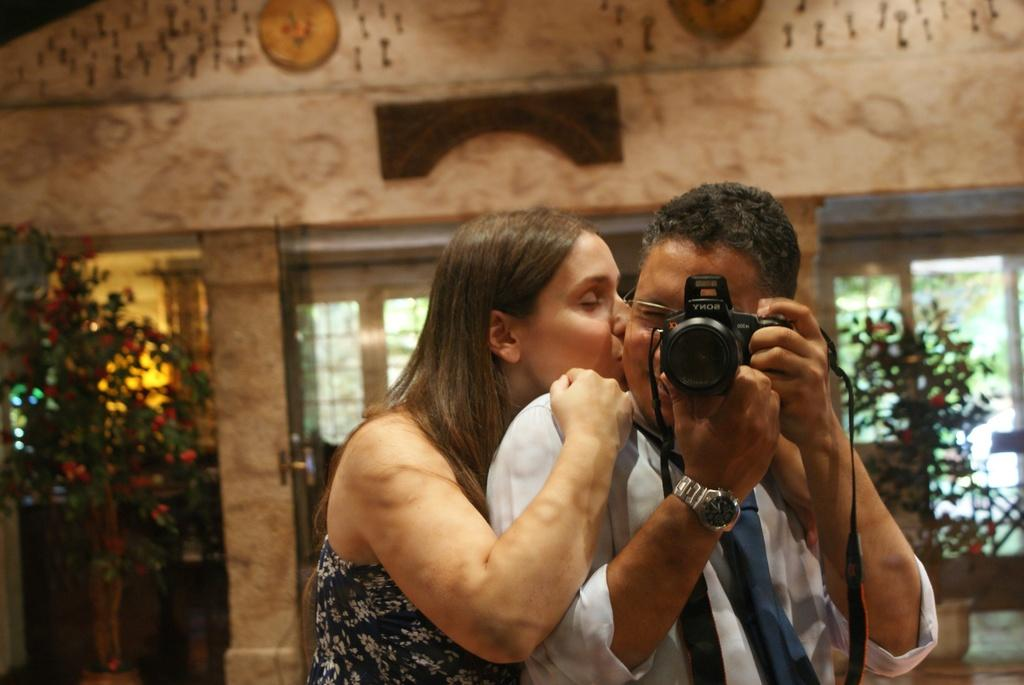How many people are in the image? There are two people in the image, a woman and a man. What is the woman doing to the man? The woman is kissing the man on his cheeks. What is the man holding in the image? The man is holding a camera. What is the man doing with the camera? The man is clicking a photo. What can be seen in the background of the image? There are trees and a wall in the background of the image. What type of scarf is the man wearing in the image? There is no scarf visible in the image; the man is holding a camera and clicking a photo. What subject is the man teaching in the image? There is no indication in the image that the man is teaching anything. 